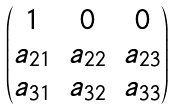Convert formula to latex. <formula><loc_0><loc_0><loc_500><loc_500>\begin{pmatrix} 1 & 0 & 0 \\ a _ { 2 1 } & a _ { 2 2 } & a _ { 2 3 } \\ a _ { 3 1 } & a _ { 3 2 } & a _ { 3 3 } \end{pmatrix}</formula> 